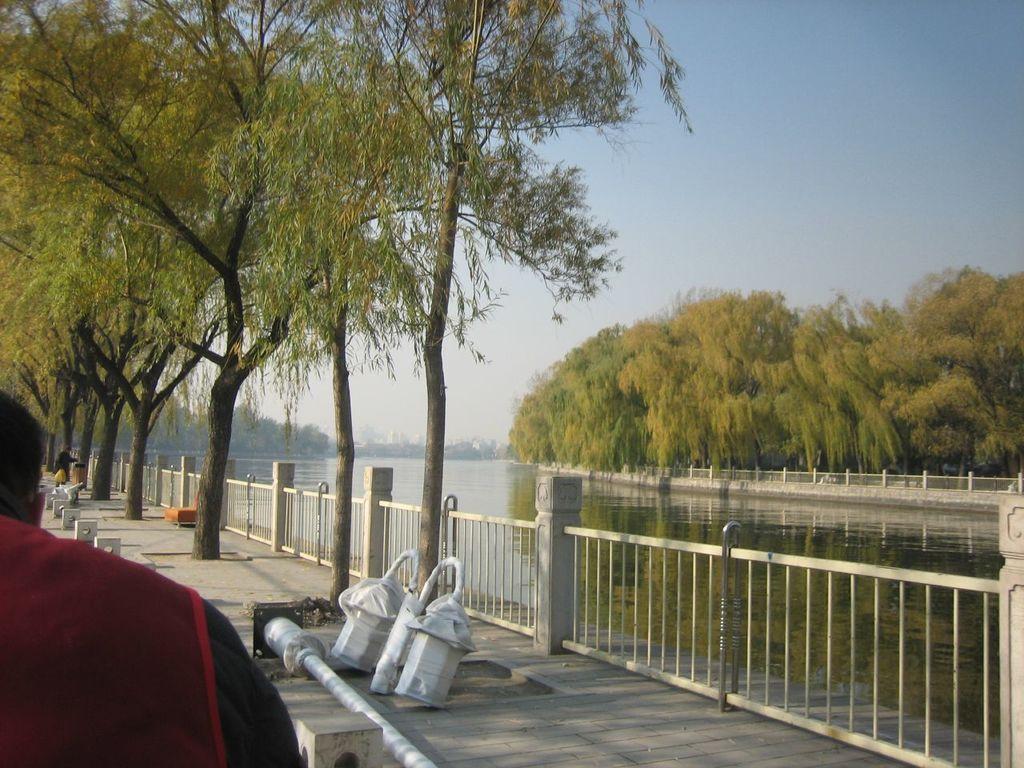Could you give a brief overview of what you see in this image? Here we can see a fence, water, trees, and two persons. In the background there is sky. 